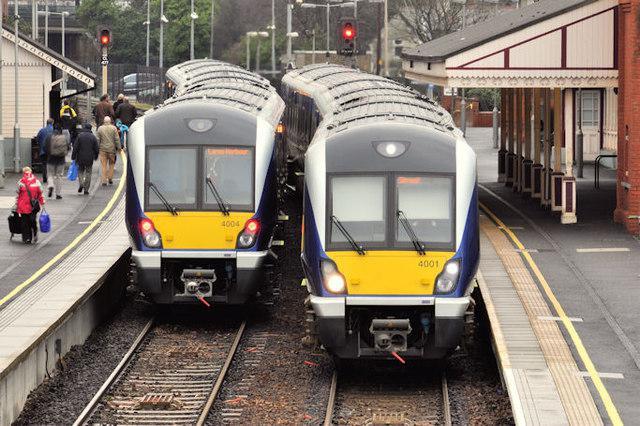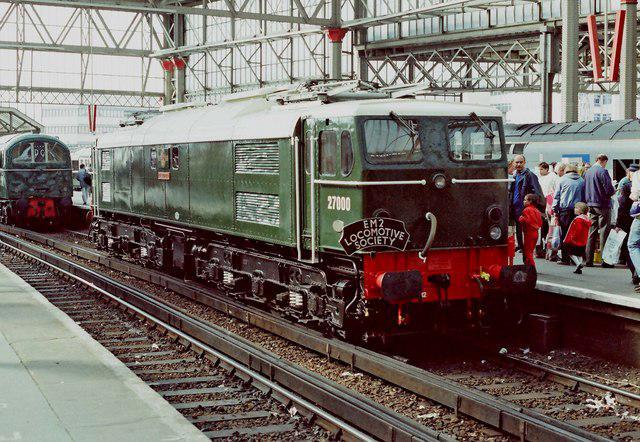The first image is the image on the left, the second image is the image on the right. Given the left and right images, does the statement "In total, the images contain two trains featuring blue and yellow coloring." hold true? Answer yes or no. Yes. 